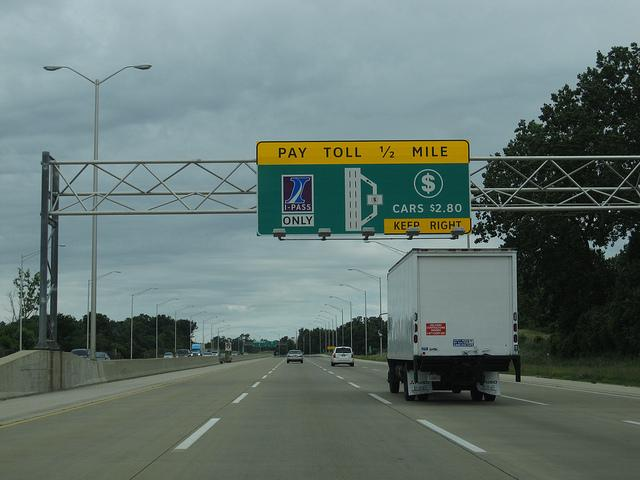What company handles the event that will happen in 1/2 mile? Please explain your reasoning. ez pass. The company is ez pass. 